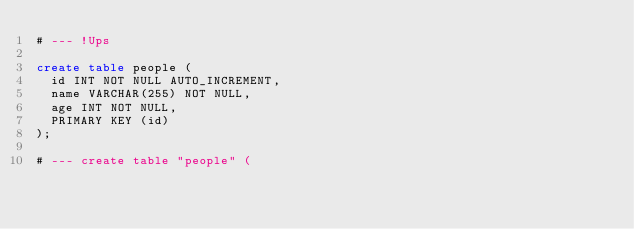Convert code to text. <code><loc_0><loc_0><loc_500><loc_500><_SQL_># --- !Ups

create table people (
  id INT NOT NULL AUTO_INCREMENT,
  name VARCHAR(255) NOT NULL,
  age INT NOT NULL,
  PRIMARY KEY (id)
);

# --- create table "people" (</code> 